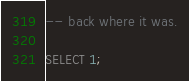Convert code to text. <code><loc_0><loc_0><loc_500><loc_500><_SQL_>-- back where it was.

SELECT 1;
</code> 